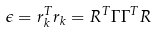<formula> <loc_0><loc_0><loc_500><loc_500>\epsilon = r _ { k } ^ { T } r _ { k } = R ^ { T } \Gamma \Gamma ^ { T } R</formula> 